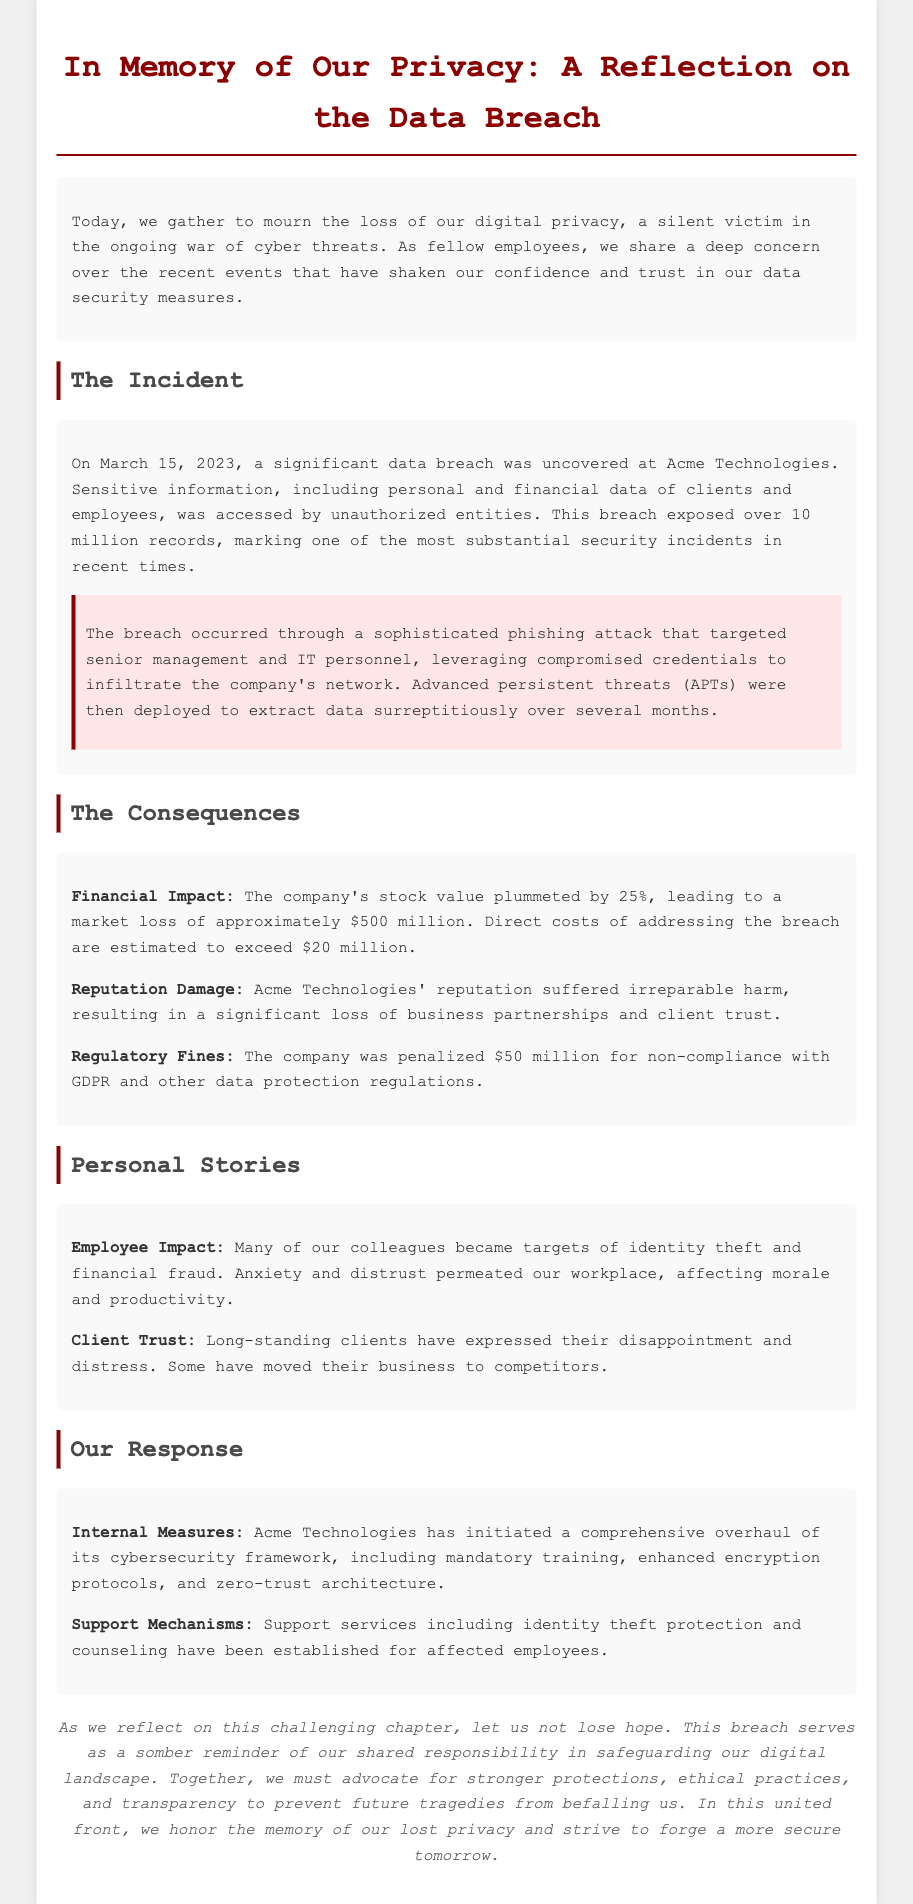What date did the data breach occur? The document states that the breach occurred on March 15, 2023.
Answer: March 15, 2023 How many records were exposed in the breach? The document mentions that over 10 million records were accessed during the data breach.
Answer: over 10 million records What was the financial impact on Acme Technologies' stock value? The document reports that the company's stock value plummeted by 25%.
Answer: 25% What was the total penalty for non-compliance with regulations? The document specifies that the company was penalized $50 million for non-compliance with GDPR and other regulations.
Answer: $50 million What primary method was used for the data breach? The document indicates that the breach occurred through a sophisticated phishing attack.
Answer: phishing attack Why did Acme Technologies suffer reputation damage? The document states that the company suffered an irreparable harm to its reputation, leading to loss of business partnerships and client trust.
Answer: loss of business partnerships and client trust What support services were established for affected employees? The document mentions that identity theft protection and counseling services have been established for affected employees.
Answer: identity theft protection and counseling What internal cybersecurity measure is mentioned? The document lists enhanced encryption protocols as part of the cybersecurity overhaul.
Answer: enhanced encryption protocols What emotional impact did the breach have on employees? The document reveals that anxiety and distrust permeated the workplace, affecting morale and productivity.
Answer: anxiety and distrust 